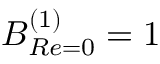Convert formula to latex. <formula><loc_0><loc_0><loc_500><loc_500>B _ { R e = 0 } ^ { ( 1 ) } = 1</formula> 